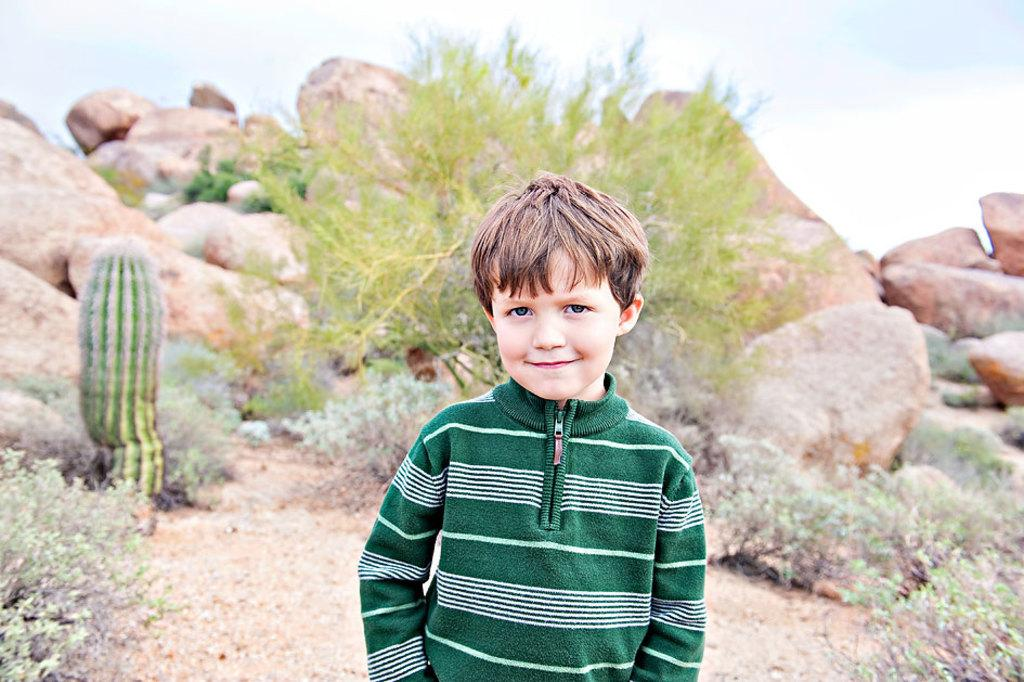Who is the main subject in the image? There is a small boy in the center of the image. What can be seen in the background of the image? There are plants, stones, and the sky visible in the background of the image. What type of wrist is the small boy wearing in the image? There is no mention of a wrist or any accessory in the image, so it cannot be determined. 